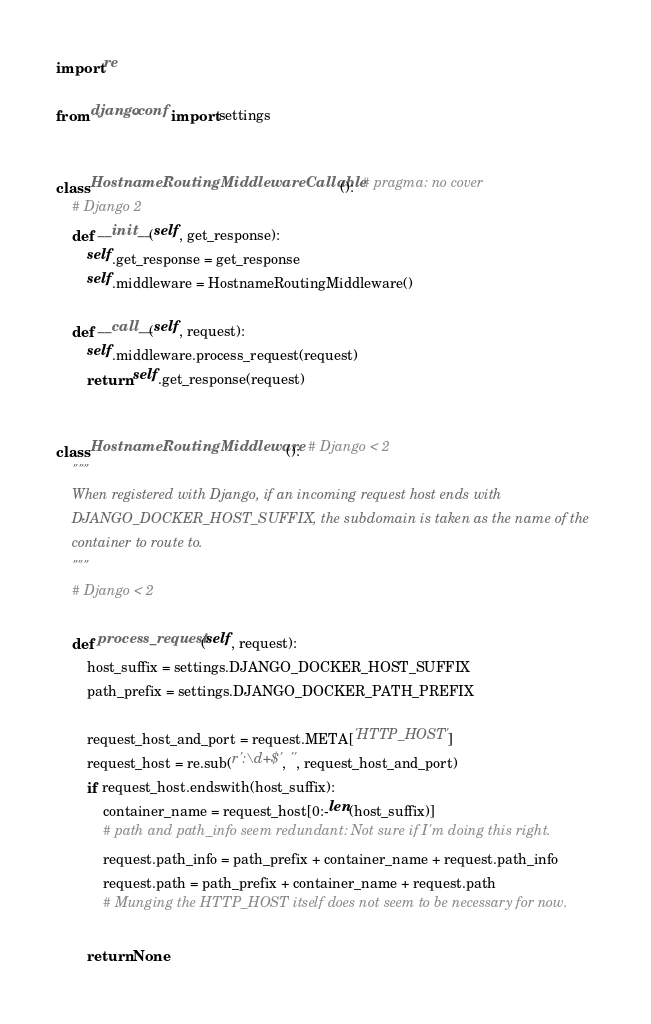Convert code to text. <code><loc_0><loc_0><loc_500><loc_500><_Python_>import re

from django.conf import settings


class HostnameRoutingMiddlewareCallable():  # pragma: no cover
    # Django 2
    def __init__(self, get_response):
        self.get_response = get_response
        self.middleware = HostnameRoutingMiddleware()

    def __call__(self, request):
        self.middleware.process_request(request)
        return self.get_response(request)


class HostnameRoutingMiddleware():  # Django < 2
    """
    When registered with Django, if an incoming request host ends with
    DJANGO_DOCKER_HOST_SUFFIX, the subdomain is taken as the name of the
    container to route to.
    """
    # Django < 2

    def process_request(self, request):
        host_suffix = settings.DJANGO_DOCKER_HOST_SUFFIX
        path_prefix = settings.DJANGO_DOCKER_PATH_PREFIX

        request_host_and_port = request.META['HTTP_HOST']
        request_host = re.sub(r':\d+$', '', request_host_and_port)
        if request_host.endswith(host_suffix):
            container_name = request_host[0:-len(host_suffix)]
            # path and path_info seem redundant: Not sure if I'm doing this right.
            request.path_info = path_prefix + container_name + request.path_info
            request.path = path_prefix + container_name + request.path
            # Munging the HTTP_HOST itself does not seem to be necessary for now.

        return None
</code> 